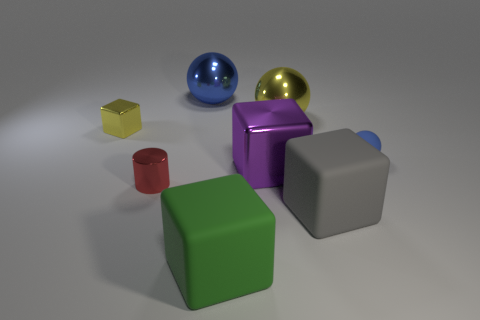Add 1 big metal blocks. How many objects exist? 9 Subtract all balls. How many objects are left? 5 Subtract all small red metallic cubes. Subtract all yellow balls. How many objects are left? 7 Add 3 big things. How many big things are left? 8 Add 3 blue metallic things. How many blue metallic things exist? 4 Subtract 1 yellow spheres. How many objects are left? 7 